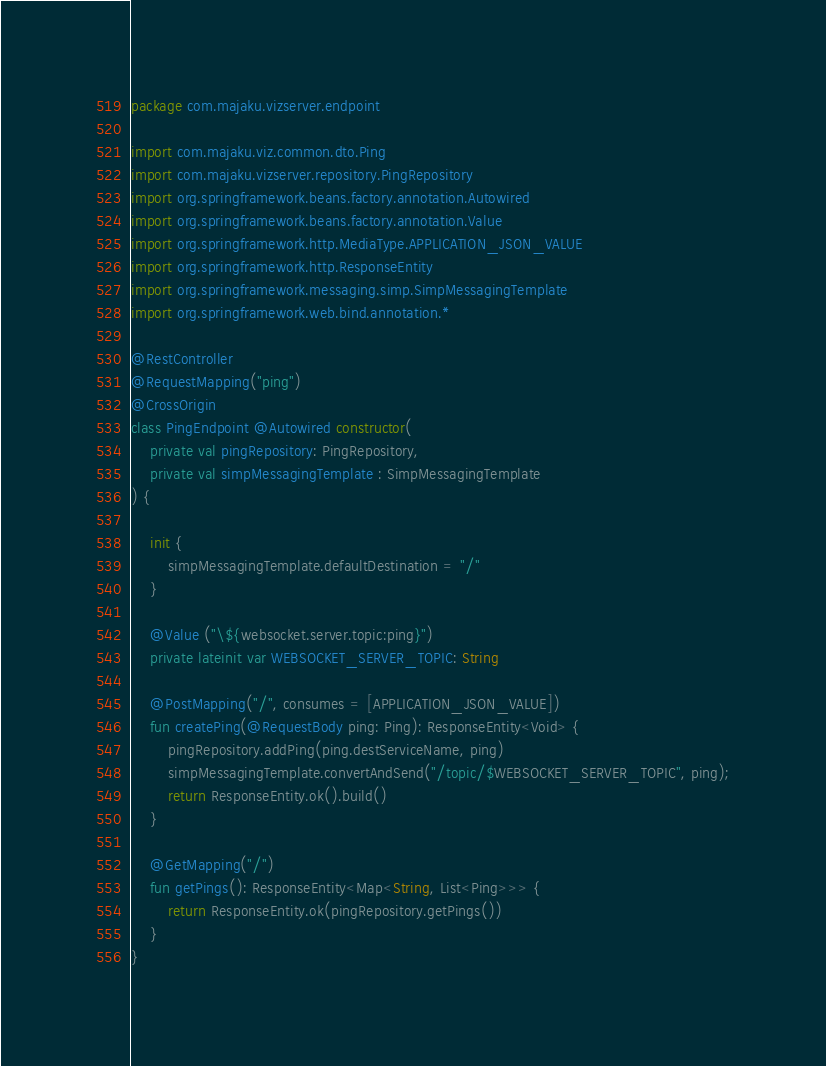Convert code to text. <code><loc_0><loc_0><loc_500><loc_500><_Kotlin_>package com.majaku.vizserver.endpoint

import com.majaku.viz.common.dto.Ping
import com.majaku.vizserver.repository.PingRepository
import org.springframework.beans.factory.annotation.Autowired
import org.springframework.beans.factory.annotation.Value
import org.springframework.http.MediaType.APPLICATION_JSON_VALUE
import org.springframework.http.ResponseEntity
import org.springframework.messaging.simp.SimpMessagingTemplate
import org.springframework.web.bind.annotation.*

@RestController
@RequestMapping("ping")
@CrossOrigin
class PingEndpoint @Autowired constructor(
    private val pingRepository: PingRepository,
    private val simpMessagingTemplate : SimpMessagingTemplate
) {

    init {
        simpMessagingTemplate.defaultDestination = "/"
    }

    @Value ("\${websocket.server.topic:ping}")
    private lateinit var WEBSOCKET_SERVER_TOPIC: String

    @PostMapping("/", consumes = [APPLICATION_JSON_VALUE])
    fun createPing(@RequestBody ping: Ping): ResponseEntity<Void> {
        pingRepository.addPing(ping.destServiceName, ping)
        simpMessagingTemplate.convertAndSend("/topic/$WEBSOCKET_SERVER_TOPIC", ping);
        return ResponseEntity.ok().build()
    }

    @GetMapping("/")
    fun getPings(): ResponseEntity<Map<String, List<Ping>>> {
        return ResponseEntity.ok(pingRepository.getPings())
    }
}</code> 